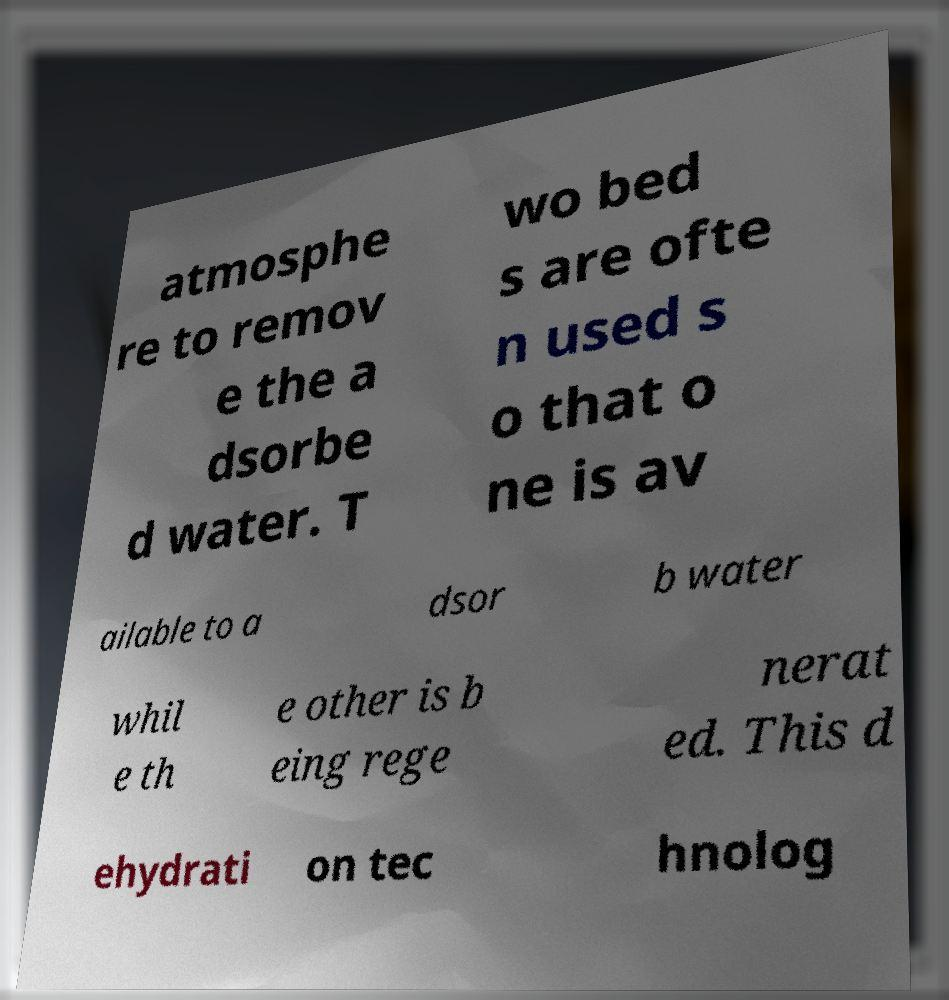Could you assist in decoding the text presented in this image and type it out clearly? atmosphe re to remov e the a dsorbe d water. T wo bed s are ofte n used s o that o ne is av ailable to a dsor b water whil e th e other is b eing rege nerat ed. This d ehydrati on tec hnolog 